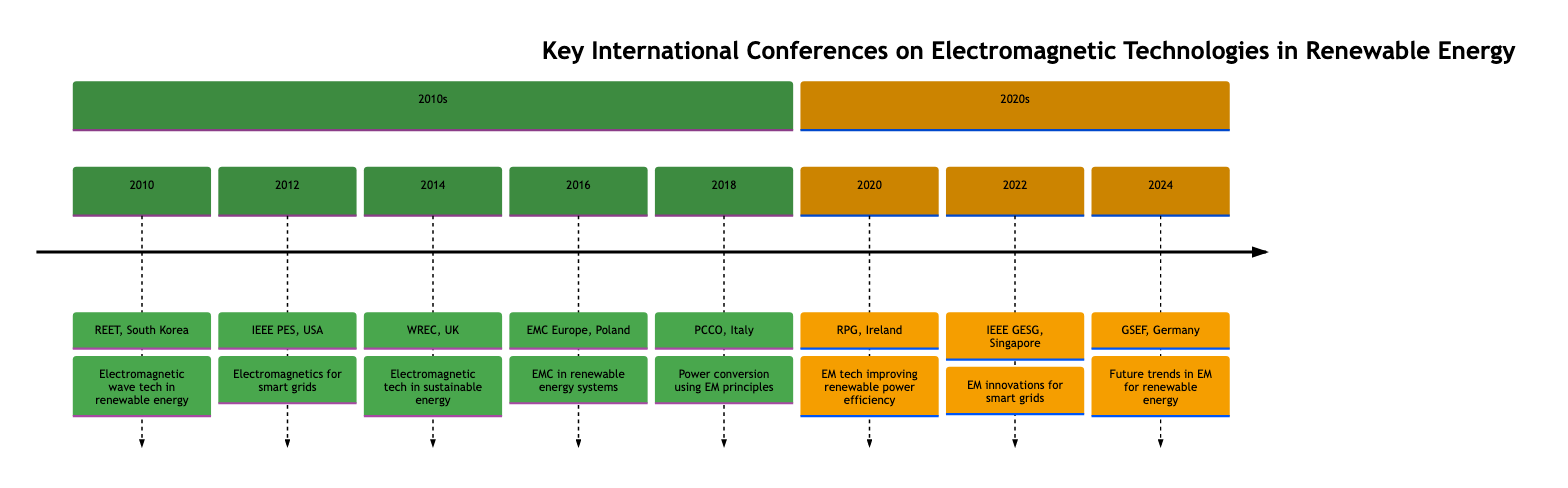What year was the International Conference on Renewable Power Generation held? The event "International Conference on Renewable Power Generation" is listed under the year 2020 in the timeline. Therefore, the answer is 2020.
Answer: 2020 What country hosted the IEEE Power and Energy Society General Meeting? The diagram indicates that the "IEEE Power and Energy Society General Meeting" took place in the USA, as noted next to the event in the timeline for the year 2012.
Answer: USA How many events are listed in the 2010s section of the timeline? By reviewing the timeline, the 2010s section includes five events: REET (2010), IEEE PES (2012), WREC (2014), EMC Europe (2016), and PCCO (2018). Therefore, the total count is 5.
Answer: 5 What was the main focus of the event in 2022? The event "IEEE International Conference on Green Energy and Smart Grids" in 2022 emphasized innovations in electromagnetic technologies for smart grids, as highlighted in the description.
Answer: Innovations in electromagnetic technologies for smart grids What significant topic did the Global Symposium on Electromagnetic Fields in Renewable Energy address? The timeline indicates that the "Global Symposium on Electromagnetic Fields in Renewable Energy" focused on future trends and research in electromagnetic applications within the renewable energy sector, as stated in its highlights for 2024.
Answer: Future trends and research in electromagnetic applications within renewable energy Which event in the 2010s discussed electromagnetic compatibility? The "International Symposium on Electromagnetic Compatibility (EMC Europe)" event listed in 2016 addresses electromagnetic compatibility specifically in renewable energy systems, as noted in the highlights of that year.
Answer: EMC Europe What location was selected for the World Renewable Energy Congress in 2014? The event "World Renewable Energy Congress (WREC)" took place in London, UK, as specified next to the event in the timeline for the year 2014.
Answer: London, UK What technology was highlighted in the International Conference on Renewable Power Generation? The highlights of the "International Conference on Renewable Power Generation" in 2020 specifically mention the role of electromagnetic technologies in improving renewable power generation efficiency.
Answer: EM tech improving renewable power generation efficiency 